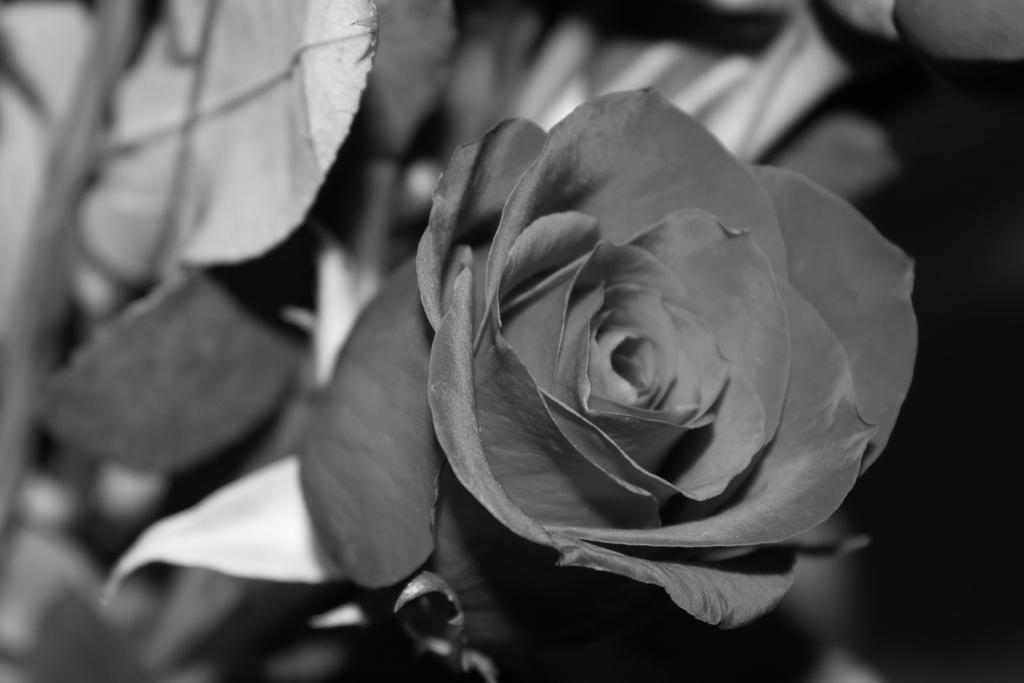What is the color scheme of the image? The image is black and white. What is the main subject of the image? There is a zoomed-in picture of a flower in the middle of the image. Can you see a squirrel holding a bucket in the image? No, there is no squirrel or bucket present in the image. What type of work is being done in the image? The image does not depict any work being done; it is a close-up of a flower. 